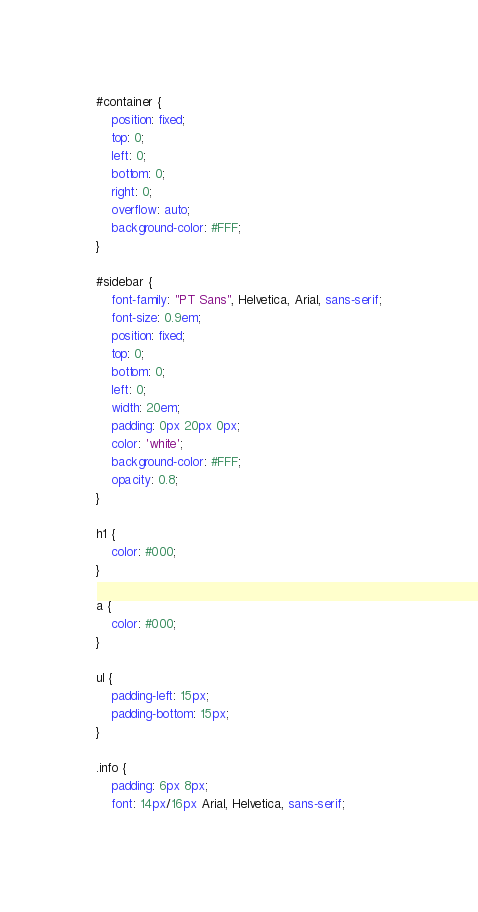Convert code to text. <code><loc_0><loc_0><loc_500><loc_500><_CSS_>#container {
	position: fixed;
	top: 0;
	left: 0;
	bottom: 0;
	right: 0;
	overflow: auto;
	background-color: #FFF;
}

#sidebar {
	font-family: "PT Sans", Helvetica, Arial, sans-serif;
	font-size: 0.9em;
	position: fixed;
	top: 0;
	bottom: 0;
	left: 0;
	width: 20em;
	padding: 0px 20px 0px;
	color: 'white';
	background-color: #FFF;
	opacity: 0.8;
}

h1 {
	color: #000;
}

a {
	color: #000;
}

ul {
	padding-left: 15px;
	padding-bottom: 15px;
}

.info { 
	padding: 6px 8px; 
	font: 14px/16px Arial, Helvetica, sans-serif; </code> 